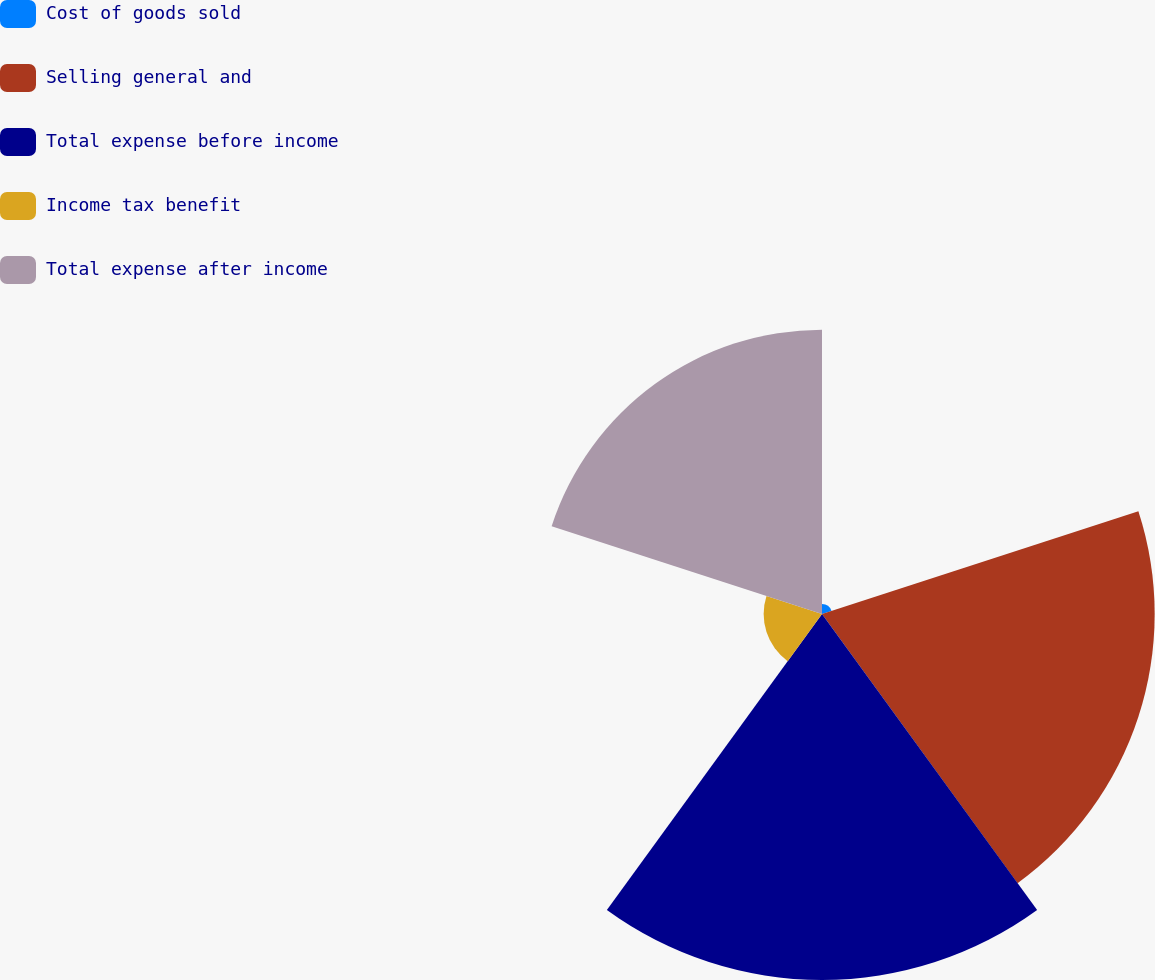Convert chart to OTSL. <chart><loc_0><loc_0><loc_500><loc_500><pie_chart><fcel>Cost of goods sold<fcel>Selling general and<fcel>Total expense before income<fcel>Income tax benefit<fcel>Total expense after income<nl><fcel>0.95%<fcel>31.64%<fcel>34.81%<fcel>5.55%<fcel>27.04%<nl></chart> 